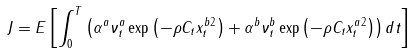<formula> <loc_0><loc_0><loc_500><loc_500>J = E \left [ \int _ { 0 } ^ { T } \left ( \alpha ^ { a } \nu _ { t } ^ { a } \exp \left ( - \rho \| C _ { t } x _ { t } ^ { b } \| ^ { 2 } \right ) + \alpha ^ { b } \nu _ { t } ^ { b } \exp \left ( - \rho \| C _ { t } x _ { t } ^ { a } \| ^ { 2 } \right ) \right ) d t \right ]</formula> 